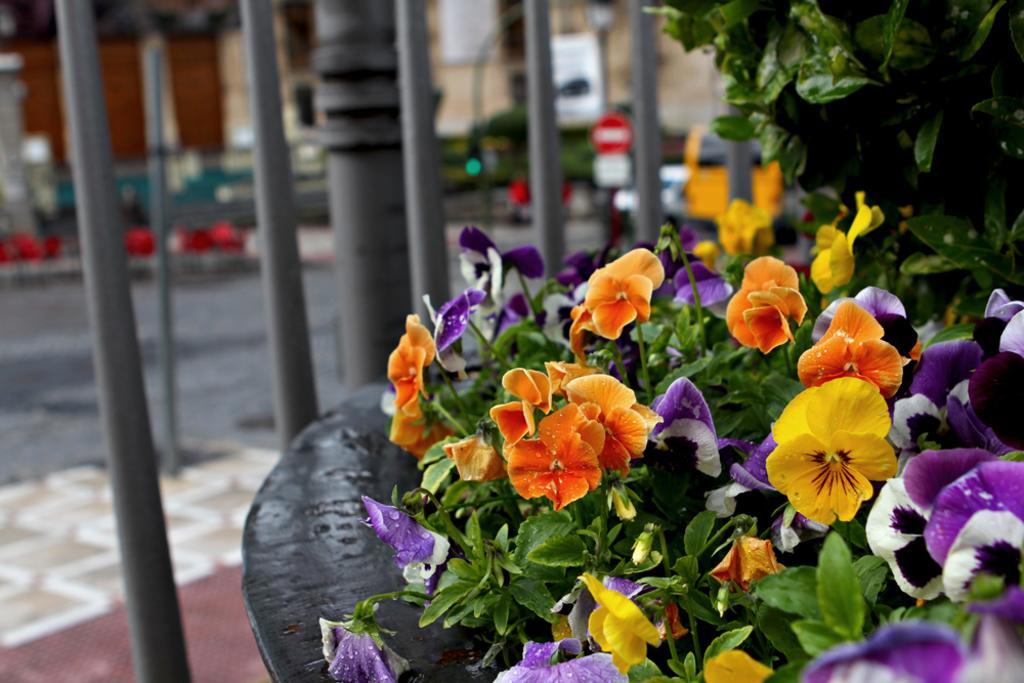Please provide a concise description of this image. In this image there are plants with colorful flowers, and in the background there are poles, boards, road and a house. 